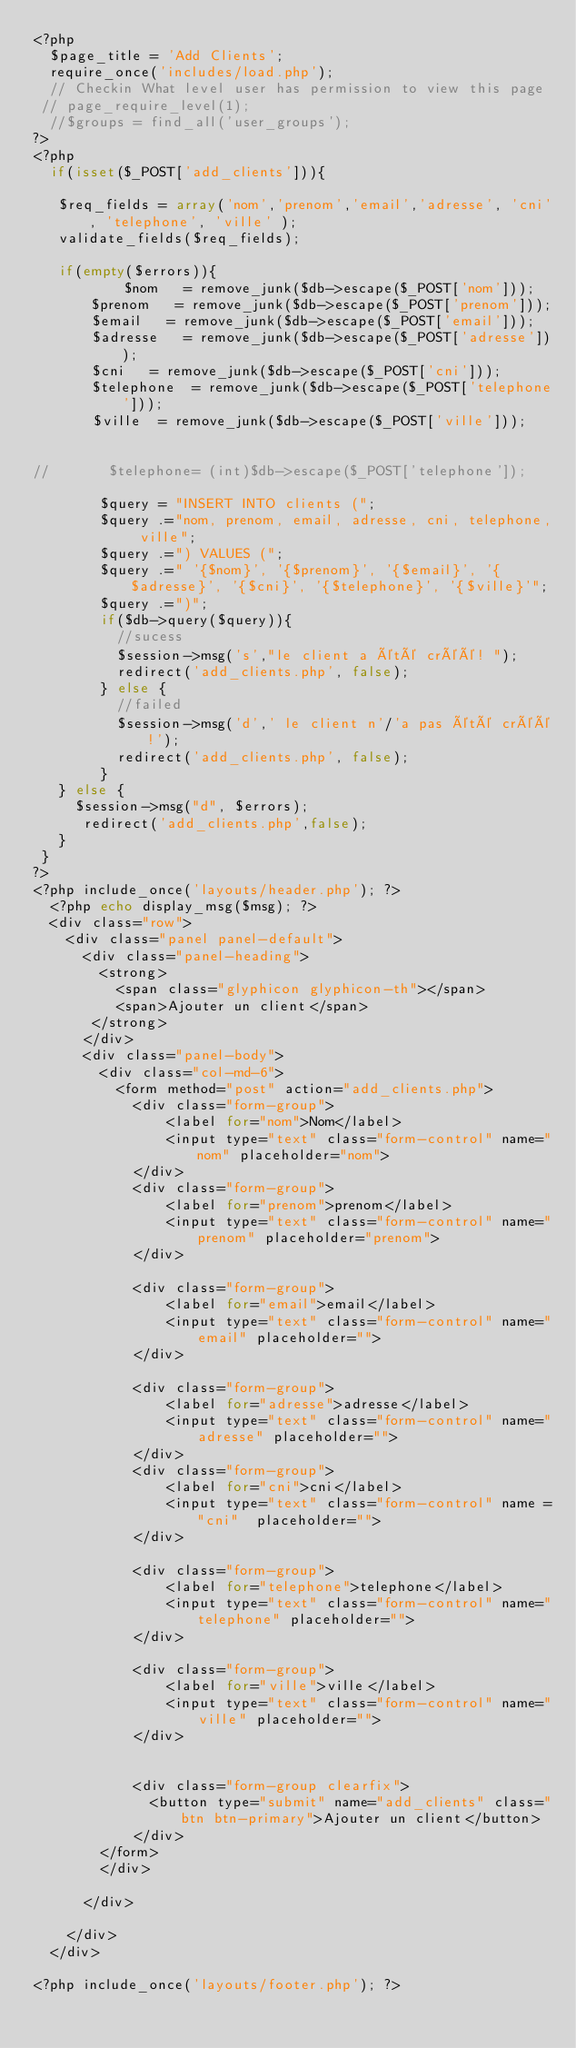Convert code to text. <code><loc_0><loc_0><loc_500><loc_500><_PHP_><?php
  $page_title = 'Add Clients';
  require_once('includes/load.php');
  // Checkin What level user has permission to view this page
 // page_require_level(1);
  //$groups = find_all('user_groups');
?>
<?php
  if(isset($_POST['add_clients'])){

   $req_fields = array('nom','prenom','email','adresse', 'cni', 'telephone', 'ville' );
   validate_fields($req_fields);

   if(empty($errors)){
           $nom   = remove_junk($db->escape($_POST['nom']));
       $prenom   = remove_junk($db->escape($_POST['prenom']));
       $email   = remove_junk($db->escape($_POST['email']));
       $adresse   = remove_junk($db->escape($_POST['adresse']));
       $cni   = remove_junk($db->escape($_POST['cni']));
       $telephone  = remove_junk($db->escape($_POST['telephone']));
       $ville  = remove_junk($db->escape($_POST['ville']));


//       $telephone= (int)$db->escape($_POST['telephone']);

        $query = "INSERT INTO clients (";
        $query .="nom, prenom, email, adresse, cni, telephone, ville";
        $query .=") VALUES (";
        $query .=" '{$nom}', '{$prenom}', '{$email}', '{$adresse}', '{$cni}', '{$telephone}', '{$ville}'";
        $query .=")";
        if($db->query($query)){
          //sucess
          $session->msg('s',"le client a été créé! ");
          redirect('add_clients.php', false);
        } else {
          //failed
          $session->msg('d',' le client n'/'a pas été créé!');
          redirect('add_clients.php', false);
        }
   } else {
     $session->msg("d", $errors);
      redirect('add_clients.php',false);
   }
 }
?>
<?php include_once('layouts/header.php'); ?>
  <?php echo display_msg($msg); ?>
  <div class="row">
    <div class="panel panel-default">
      <div class="panel-heading">
        <strong>
          <span class="glyphicon glyphicon-th"></span>
          <span>Ajouter un client</span>
       </strong>
      </div>
      <div class="panel-body">
        <div class="col-md-6">
          <form method="post" action="add_clients.php">
            <div class="form-group">
                <label for="nom">Nom</label>
                <input type="text" class="form-control" name="nom" placeholder="nom">
            </div>
            <div class="form-group">
                <label for="prenom">prenom</label>
                <input type="text" class="form-control" name="prenom" placeholder="prenom">
            </div>

            <div class="form-group">
                <label for="email">email</label>
                <input type="text" class="form-control" name="email" placeholder="">
            </div>

            <div class="form-group">
                <label for="adresse">adresse</label>
                <input type="text" class="form-control" name="adresse" placeholder="">
            </div>
            <div class="form-group">
                <label for="cni">cni</label>
                <input type="text" class="form-control" name ="cni"  placeholder="">
            </div>

            <div class="form-group">
                <label for="telephone">telephone</label>
                <input type="text" class="form-control" name="telephone" placeholder="">
            </div>

            <div class="form-group">
                <label for="ville">ville</label>
                <input type="text" class="form-control" name="ville" placeholder="">
            </div>

            
            <div class="form-group clearfix">
              <button type="submit" name="add_clients" class="btn btn-primary">Ajouter un client</button>
            </div>
        </form>
        </div>

      </div>

    </div>
  </div>

<?php include_once('layouts/footer.php'); ?>
</code> 